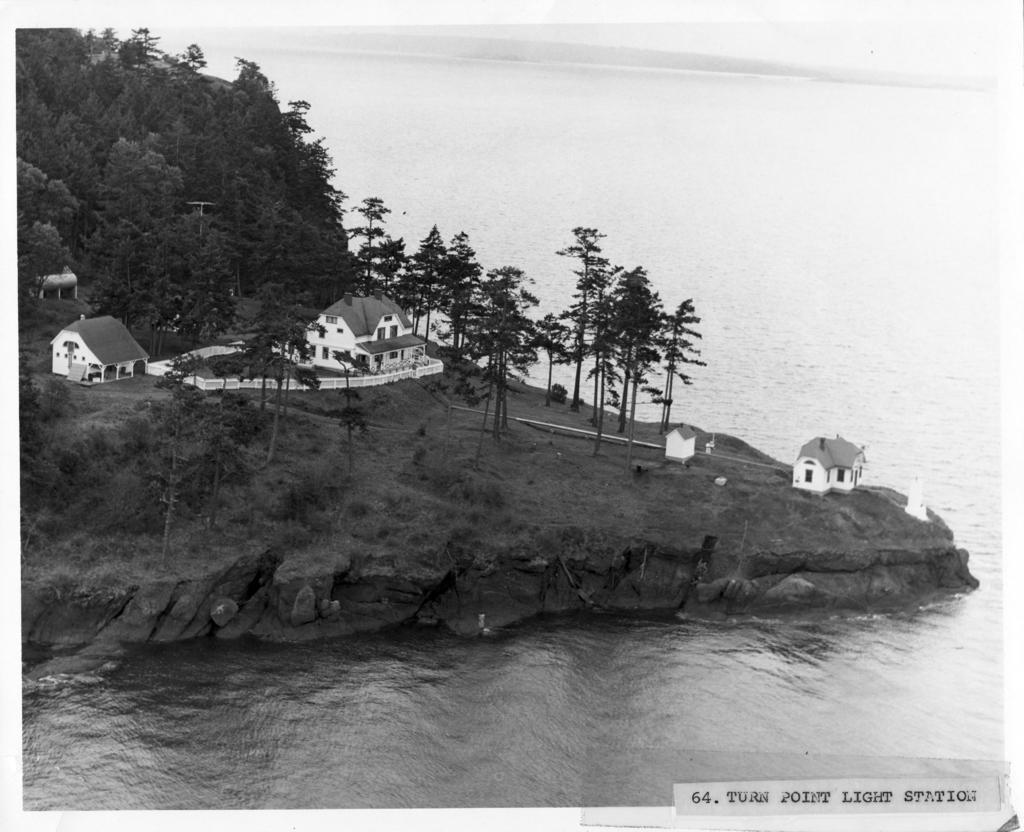Describe this image in one or two sentences. Here in this picture we can see water covered over a place and on the ground we can see grass, plants and trees covered and we can also see houses present. 